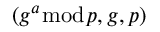<formula> <loc_0><loc_0><loc_500><loc_500>( g ^ { a } { \bmod { p } } , g , p )</formula> 